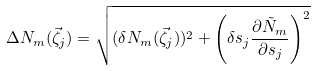Convert formula to latex. <formula><loc_0><loc_0><loc_500><loc_500>\Delta N _ { m } ( \vec { \zeta } _ { j } ) = \sqrt { ( \delta N _ { m } ( \vec { \zeta } _ { j } ) ) ^ { 2 } + \left ( \delta s _ { j } \frac { \partial \tilde { N } _ { m } } { \partial s _ { j } } \right ) ^ { 2 } }</formula> 